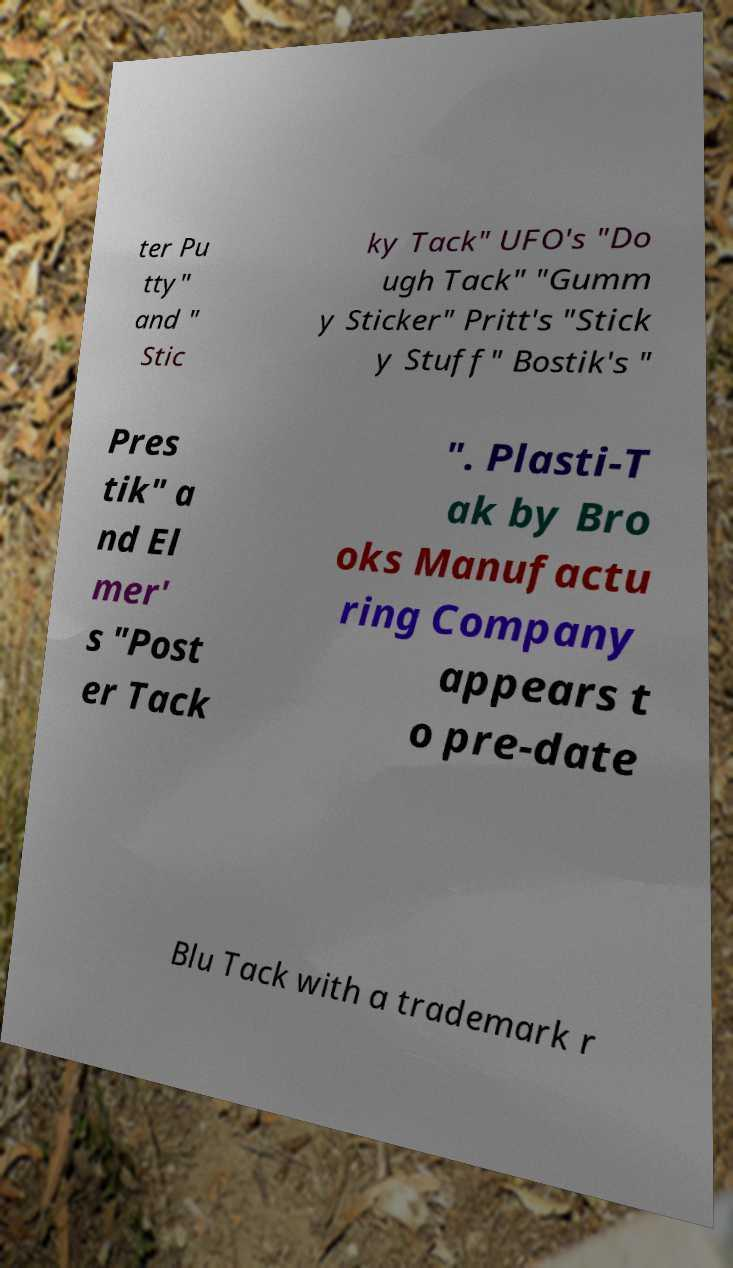Please read and relay the text visible in this image. What does it say? ter Pu tty" and " Stic ky Tack" UFO's "Do ugh Tack" "Gumm y Sticker" Pritt's "Stick y Stuff" Bostik's " Pres tik" a nd El mer' s "Post er Tack ". Plasti-T ak by Bro oks Manufactu ring Company appears t o pre-date Blu Tack with a trademark r 